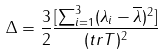<formula> <loc_0><loc_0><loc_500><loc_500>\Delta = \frac { 3 } { 2 } \frac { [ \sum _ { i = 1 } ^ { 3 } ( \lambda _ { i } - \overline { \lambda } ) ^ { 2 } ] } { ( t r { T } ) ^ { 2 } }</formula> 